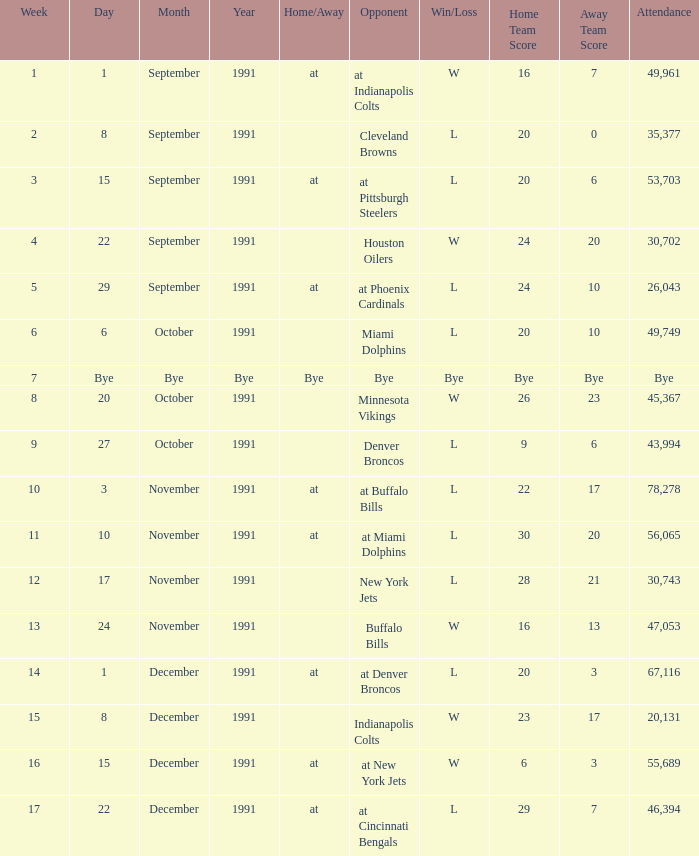Who did the Patriots play in week 4? Houston Oilers. 